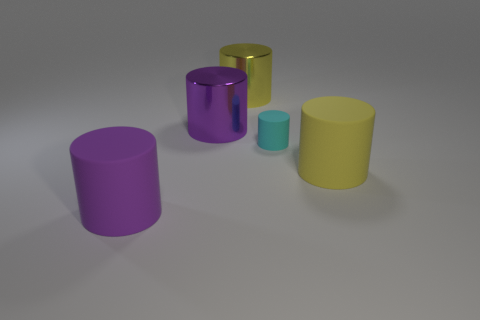What number of other things are there of the same shape as the small cyan rubber thing?
Your response must be concise. 4. There is a large yellow rubber object that is in front of the small cylinder; are there any big metallic things that are to the right of it?
Offer a terse response. No. What number of yellow rubber objects are there?
Provide a short and direct response. 1. There is a tiny matte cylinder; does it have the same color as the metal thing to the right of the purple metal object?
Your response must be concise. No. Is the number of purple matte cylinders greater than the number of big purple things?
Keep it short and to the point. No. Is there any other thing that has the same color as the tiny matte cylinder?
Keep it short and to the point. No. How many other things are there of the same size as the yellow rubber cylinder?
Offer a very short reply. 3. What is the material of the large yellow thing that is to the right of the large yellow metal cylinder that is behind the big rubber cylinder that is left of the purple metal cylinder?
Make the answer very short. Rubber. Does the cyan cylinder have the same material as the purple object behind the tiny matte object?
Provide a short and direct response. No. Are there fewer yellow shiny cylinders in front of the yellow matte thing than purple rubber cylinders right of the small cyan rubber cylinder?
Make the answer very short. No. 